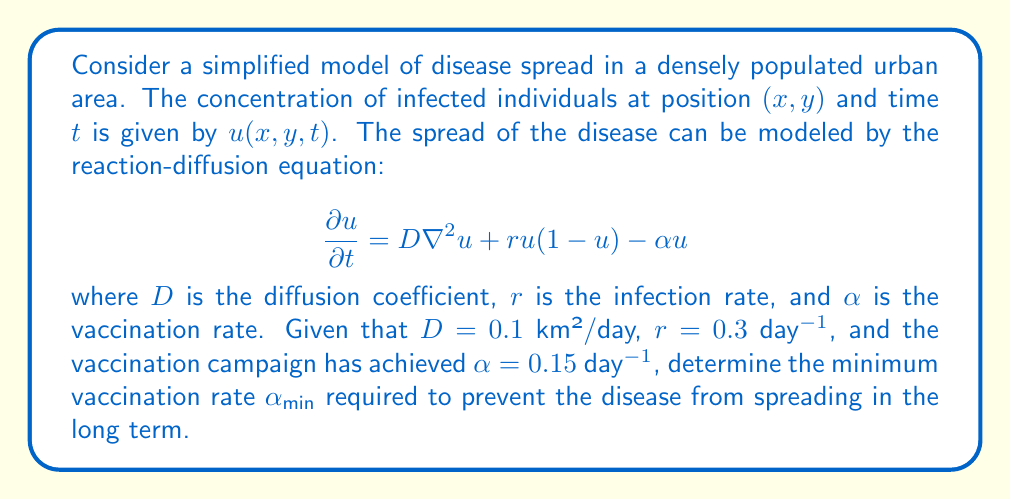Solve this math problem. To solve this problem, we need to analyze the conditions under which the disease will stop spreading. In the long term, we're interested in the steady-state solution where $\frac{\partial u}{\partial t} = 0$.

1) At steady state, the equation becomes:

   $$0 = D\nabla^2u + ru(1-u) - \alpha u$$

2) For a non-trivial solution (u ≠ 0), we can ignore the spatial variation (assuming a homogeneous distribution) and set $\nabla^2u = 0$:

   $$0 = ru(1-u) - \alpha u$$

3) Factoring out $u$:

   $$0 = u(r(1-u) - \alpha)$$

4) For the disease to stop spreading, we need the non-zero solution to be unstable. This occurs when:

   $$r(1-u) - \alpha < 0$$

5) The worst-case scenario (easiest for disease to spread) is when $u$ is very small, approaching 0. In this case:

   $$r - \alpha < 0$$

6) Therefore, to prevent the spread, we need:

   $$\alpha > r$$

7) Given $r = 0.3$ day⁻¹, the minimum vaccination rate needed is:

   $$\alpha_{min} = r = 0.3\text{ day}^{-1}$$

8) The current vaccination rate ($\alpha = 0.15$ day⁻¹) is less than this minimum, so it's not sufficient to prevent the spread in the long term.
Answer: The minimum vaccination rate required to prevent the disease from spreading in the long term is $\alpha_{min} = 0.3\text{ day}^{-1}$. 